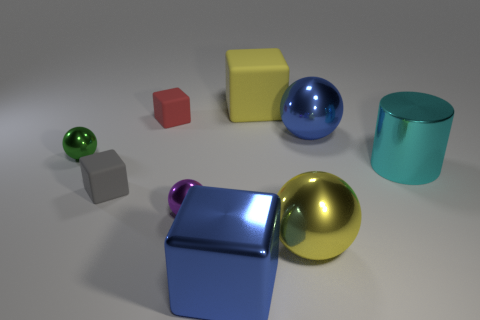There is a large ball behind the yellow shiny thing; is its color the same as the big shiny cube?
Ensure brevity in your answer.  Yes. Is the color of the big metallic ball behind the green shiny sphere the same as the big cube in front of the metal cylinder?
Make the answer very short. Yes. There is a metal object that is the same color as the big rubber object; what size is it?
Give a very brief answer. Large. How many big spheres have the same color as the big rubber block?
Your response must be concise. 1. What is the shape of the big blue thing on the right side of the big shiny cube?
Your answer should be compact. Sphere. What size is the red rubber object that is the same shape as the gray thing?
Make the answer very short. Small. There is a big blue object that is on the right side of the large yellow thing that is in front of the tiny green sphere; how many small gray matte cubes are behind it?
Give a very brief answer. 0. Are there an equal number of cyan cylinders that are right of the cyan shiny cylinder and large purple rubber blocks?
Make the answer very short. Yes. How many spheres are purple objects or gray rubber objects?
Ensure brevity in your answer.  1. Does the cylinder have the same color as the large matte object?
Your response must be concise. No. 